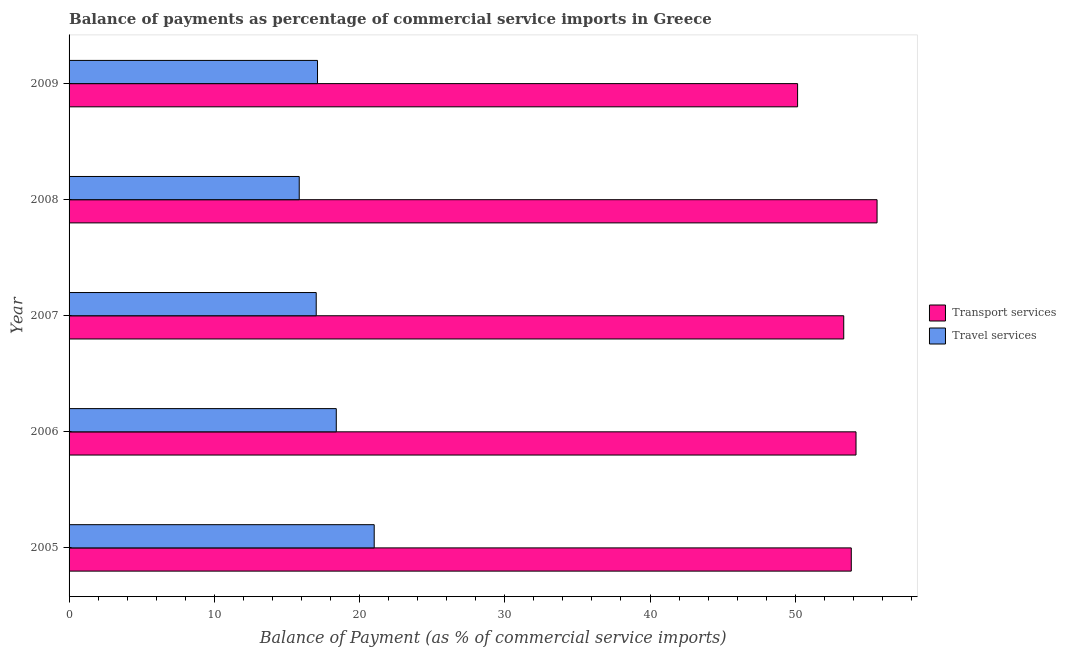How many different coloured bars are there?
Ensure brevity in your answer.  2. How many groups of bars are there?
Make the answer very short. 5. What is the label of the 3rd group of bars from the top?
Keep it short and to the point. 2007. In how many cases, is the number of bars for a given year not equal to the number of legend labels?
Your answer should be compact. 0. What is the balance of payments of travel services in 2006?
Offer a terse response. 18.4. Across all years, what is the maximum balance of payments of transport services?
Give a very brief answer. 55.63. Across all years, what is the minimum balance of payments of transport services?
Offer a very short reply. 50.16. In which year was the balance of payments of travel services minimum?
Ensure brevity in your answer.  2008. What is the total balance of payments of transport services in the graph?
Ensure brevity in your answer.  267.18. What is the difference between the balance of payments of travel services in 2005 and that in 2009?
Provide a short and direct response. 3.9. What is the difference between the balance of payments of travel services in 2005 and the balance of payments of transport services in 2006?
Provide a succinct answer. -33.18. What is the average balance of payments of transport services per year?
Your answer should be compact. 53.44. In the year 2005, what is the difference between the balance of payments of transport services and balance of payments of travel services?
Your answer should be compact. 32.85. In how many years, is the balance of payments of travel services greater than 22 %?
Keep it short and to the point. 0. Is the difference between the balance of payments of travel services in 2008 and 2009 greater than the difference between the balance of payments of transport services in 2008 and 2009?
Offer a terse response. No. What is the difference between the highest and the second highest balance of payments of transport services?
Your answer should be very brief. 1.45. What is the difference between the highest and the lowest balance of payments of travel services?
Keep it short and to the point. 5.16. What does the 1st bar from the top in 2008 represents?
Keep it short and to the point. Travel services. What does the 1st bar from the bottom in 2005 represents?
Your answer should be compact. Transport services. How many bars are there?
Your answer should be compact. 10. Are all the bars in the graph horizontal?
Your answer should be very brief. Yes. Are the values on the major ticks of X-axis written in scientific E-notation?
Offer a very short reply. No. Where does the legend appear in the graph?
Give a very brief answer. Center right. How many legend labels are there?
Your answer should be very brief. 2. How are the legend labels stacked?
Give a very brief answer. Vertical. What is the title of the graph?
Your answer should be compact. Balance of payments as percentage of commercial service imports in Greece. Does "Exports" appear as one of the legend labels in the graph?
Make the answer very short. No. What is the label or title of the X-axis?
Your answer should be compact. Balance of Payment (as % of commercial service imports). What is the label or title of the Y-axis?
Your answer should be very brief. Year. What is the Balance of Payment (as % of commercial service imports) of Transport services in 2005?
Keep it short and to the point. 53.86. What is the Balance of Payment (as % of commercial service imports) of Travel services in 2005?
Provide a short and direct response. 21.01. What is the Balance of Payment (as % of commercial service imports) of Transport services in 2006?
Ensure brevity in your answer.  54.19. What is the Balance of Payment (as % of commercial service imports) in Travel services in 2006?
Keep it short and to the point. 18.4. What is the Balance of Payment (as % of commercial service imports) in Transport services in 2007?
Ensure brevity in your answer.  53.34. What is the Balance of Payment (as % of commercial service imports) in Travel services in 2007?
Your answer should be compact. 17.02. What is the Balance of Payment (as % of commercial service imports) of Transport services in 2008?
Give a very brief answer. 55.63. What is the Balance of Payment (as % of commercial service imports) of Travel services in 2008?
Make the answer very short. 15.85. What is the Balance of Payment (as % of commercial service imports) of Transport services in 2009?
Make the answer very short. 50.16. What is the Balance of Payment (as % of commercial service imports) in Travel services in 2009?
Provide a short and direct response. 17.11. Across all years, what is the maximum Balance of Payment (as % of commercial service imports) in Transport services?
Offer a very short reply. 55.63. Across all years, what is the maximum Balance of Payment (as % of commercial service imports) of Travel services?
Give a very brief answer. 21.01. Across all years, what is the minimum Balance of Payment (as % of commercial service imports) of Transport services?
Make the answer very short. 50.16. Across all years, what is the minimum Balance of Payment (as % of commercial service imports) in Travel services?
Offer a terse response. 15.85. What is the total Balance of Payment (as % of commercial service imports) of Transport services in the graph?
Offer a terse response. 267.18. What is the total Balance of Payment (as % of commercial service imports) of Travel services in the graph?
Your answer should be very brief. 89.38. What is the difference between the Balance of Payment (as % of commercial service imports) in Transport services in 2005 and that in 2006?
Your answer should be compact. -0.33. What is the difference between the Balance of Payment (as % of commercial service imports) in Travel services in 2005 and that in 2006?
Your answer should be compact. 2.61. What is the difference between the Balance of Payment (as % of commercial service imports) of Transport services in 2005 and that in 2007?
Your answer should be compact. 0.52. What is the difference between the Balance of Payment (as % of commercial service imports) of Travel services in 2005 and that in 2007?
Your answer should be compact. 3.99. What is the difference between the Balance of Payment (as % of commercial service imports) of Transport services in 2005 and that in 2008?
Make the answer very short. -1.77. What is the difference between the Balance of Payment (as % of commercial service imports) of Travel services in 2005 and that in 2008?
Offer a terse response. 5.16. What is the difference between the Balance of Payment (as % of commercial service imports) of Transport services in 2005 and that in 2009?
Provide a short and direct response. 3.7. What is the difference between the Balance of Payment (as % of commercial service imports) of Travel services in 2005 and that in 2009?
Offer a very short reply. 3.9. What is the difference between the Balance of Payment (as % of commercial service imports) in Transport services in 2006 and that in 2007?
Offer a terse response. 0.85. What is the difference between the Balance of Payment (as % of commercial service imports) in Travel services in 2006 and that in 2007?
Make the answer very short. 1.38. What is the difference between the Balance of Payment (as % of commercial service imports) in Transport services in 2006 and that in 2008?
Provide a short and direct response. -1.45. What is the difference between the Balance of Payment (as % of commercial service imports) in Travel services in 2006 and that in 2008?
Give a very brief answer. 2.55. What is the difference between the Balance of Payment (as % of commercial service imports) of Transport services in 2006 and that in 2009?
Give a very brief answer. 4.02. What is the difference between the Balance of Payment (as % of commercial service imports) of Travel services in 2006 and that in 2009?
Give a very brief answer. 1.29. What is the difference between the Balance of Payment (as % of commercial service imports) of Transport services in 2007 and that in 2008?
Make the answer very short. -2.29. What is the difference between the Balance of Payment (as % of commercial service imports) in Travel services in 2007 and that in 2008?
Offer a very short reply. 1.17. What is the difference between the Balance of Payment (as % of commercial service imports) of Transport services in 2007 and that in 2009?
Keep it short and to the point. 3.18. What is the difference between the Balance of Payment (as % of commercial service imports) in Travel services in 2007 and that in 2009?
Your answer should be very brief. -0.09. What is the difference between the Balance of Payment (as % of commercial service imports) of Transport services in 2008 and that in 2009?
Provide a succinct answer. 5.47. What is the difference between the Balance of Payment (as % of commercial service imports) of Travel services in 2008 and that in 2009?
Keep it short and to the point. -1.26. What is the difference between the Balance of Payment (as % of commercial service imports) of Transport services in 2005 and the Balance of Payment (as % of commercial service imports) of Travel services in 2006?
Give a very brief answer. 35.46. What is the difference between the Balance of Payment (as % of commercial service imports) in Transport services in 2005 and the Balance of Payment (as % of commercial service imports) in Travel services in 2007?
Your answer should be compact. 36.84. What is the difference between the Balance of Payment (as % of commercial service imports) of Transport services in 2005 and the Balance of Payment (as % of commercial service imports) of Travel services in 2008?
Provide a short and direct response. 38.01. What is the difference between the Balance of Payment (as % of commercial service imports) of Transport services in 2005 and the Balance of Payment (as % of commercial service imports) of Travel services in 2009?
Provide a short and direct response. 36.75. What is the difference between the Balance of Payment (as % of commercial service imports) of Transport services in 2006 and the Balance of Payment (as % of commercial service imports) of Travel services in 2007?
Offer a terse response. 37.17. What is the difference between the Balance of Payment (as % of commercial service imports) in Transport services in 2006 and the Balance of Payment (as % of commercial service imports) in Travel services in 2008?
Keep it short and to the point. 38.34. What is the difference between the Balance of Payment (as % of commercial service imports) of Transport services in 2006 and the Balance of Payment (as % of commercial service imports) of Travel services in 2009?
Offer a very short reply. 37.08. What is the difference between the Balance of Payment (as % of commercial service imports) in Transport services in 2007 and the Balance of Payment (as % of commercial service imports) in Travel services in 2008?
Give a very brief answer. 37.49. What is the difference between the Balance of Payment (as % of commercial service imports) of Transport services in 2007 and the Balance of Payment (as % of commercial service imports) of Travel services in 2009?
Your response must be concise. 36.23. What is the difference between the Balance of Payment (as % of commercial service imports) of Transport services in 2008 and the Balance of Payment (as % of commercial service imports) of Travel services in 2009?
Make the answer very short. 38.53. What is the average Balance of Payment (as % of commercial service imports) in Transport services per year?
Your response must be concise. 53.44. What is the average Balance of Payment (as % of commercial service imports) in Travel services per year?
Offer a very short reply. 17.88. In the year 2005, what is the difference between the Balance of Payment (as % of commercial service imports) in Transport services and Balance of Payment (as % of commercial service imports) in Travel services?
Ensure brevity in your answer.  32.85. In the year 2006, what is the difference between the Balance of Payment (as % of commercial service imports) of Transport services and Balance of Payment (as % of commercial service imports) of Travel services?
Give a very brief answer. 35.79. In the year 2007, what is the difference between the Balance of Payment (as % of commercial service imports) in Transport services and Balance of Payment (as % of commercial service imports) in Travel services?
Your response must be concise. 36.32. In the year 2008, what is the difference between the Balance of Payment (as % of commercial service imports) in Transport services and Balance of Payment (as % of commercial service imports) in Travel services?
Offer a very short reply. 39.79. In the year 2009, what is the difference between the Balance of Payment (as % of commercial service imports) in Transport services and Balance of Payment (as % of commercial service imports) in Travel services?
Provide a succinct answer. 33.06. What is the ratio of the Balance of Payment (as % of commercial service imports) of Transport services in 2005 to that in 2006?
Your answer should be compact. 0.99. What is the ratio of the Balance of Payment (as % of commercial service imports) of Travel services in 2005 to that in 2006?
Make the answer very short. 1.14. What is the ratio of the Balance of Payment (as % of commercial service imports) in Transport services in 2005 to that in 2007?
Your answer should be very brief. 1.01. What is the ratio of the Balance of Payment (as % of commercial service imports) in Travel services in 2005 to that in 2007?
Your answer should be very brief. 1.23. What is the ratio of the Balance of Payment (as % of commercial service imports) of Transport services in 2005 to that in 2008?
Offer a very short reply. 0.97. What is the ratio of the Balance of Payment (as % of commercial service imports) of Travel services in 2005 to that in 2008?
Offer a terse response. 1.33. What is the ratio of the Balance of Payment (as % of commercial service imports) in Transport services in 2005 to that in 2009?
Your answer should be compact. 1.07. What is the ratio of the Balance of Payment (as % of commercial service imports) in Travel services in 2005 to that in 2009?
Your response must be concise. 1.23. What is the ratio of the Balance of Payment (as % of commercial service imports) of Transport services in 2006 to that in 2007?
Your answer should be very brief. 1.02. What is the ratio of the Balance of Payment (as % of commercial service imports) in Travel services in 2006 to that in 2007?
Make the answer very short. 1.08. What is the ratio of the Balance of Payment (as % of commercial service imports) in Travel services in 2006 to that in 2008?
Make the answer very short. 1.16. What is the ratio of the Balance of Payment (as % of commercial service imports) of Transport services in 2006 to that in 2009?
Provide a short and direct response. 1.08. What is the ratio of the Balance of Payment (as % of commercial service imports) in Travel services in 2006 to that in 2009?
Offer a very short reply. 1.08. What is the ratio of the Balance of Payment (as % of commercial service imports) in Transport services in 2007 to that in 2008?
Your answer should be compact. 0.96. What is the ratio of the Balance of Payment (as % of commercial service imports) in Travel services in 2007 to that in 2008?
Your response must be concise. 1.07. What is the ratio of the Balance of Payment (as % of commercial service imports) in Transport services in 2007 to that in 2009?
Offer a very short reply. 1.06. What is the ratio of the Balance of Payment (as % of commercial service imports) of Transport services in 2008 to that in 2009?
Your answer should be very brief. 1.11. What is the ratio of the Balance of Payment (as % of commercial service imports) in Travel services in 2008 to that in 2009?
Give a very brief answer. 0.93. What is the difference between the highest and the second highest Balance of Payment (as % of commercial service imports) of Transport services?
Your response must be concise. 1.45. What is the difference between the highest and the second highest Balance of Payment (as % of commercial service imports) in Travel services?
Your response must be concise. 2.61. What is the difference between the highest and the lowest Balance of Payment (as % of commercial service imports) of Transport services?
Provide a succinct answer. 5.47. What is the difference between the highest and the lowest Balance of Payment (as % of commercial service imports) in Travel services?
Ensure brevity in your answer.  5.16. 